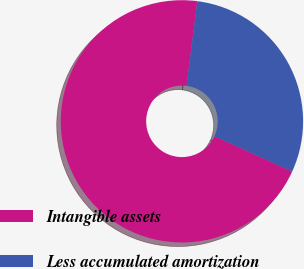Convert chart to OTSL. <chart><loc_0><loc_0><loc_500><loc_500><pie_chart><fcel>Intangible assets<fcel>Less accumulated amortization<nl><fcel>70.23%<fcel>29.77%<nl></chart> 